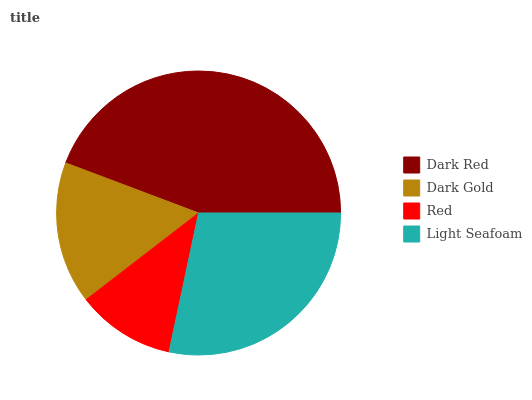Is Red the minimum?
Answer yes or no. Yes. Is Dark Red the maximum?
Answer yes or no. Yes. Is Dark Gold the minimum?
Answer yes or no. No. Is Dark Gold the maximum?
Answer yes or no. No. Is Dark Red greater than Dark Gold?
Answer yes or no. Yes. Is Dark Gold less than Dark Red?
Answer yes or no. Yes. Is Dark Gold greater than Dark Red?
Answer yes or no. No. Is Dark Red less than Dark Gold?
Answer yes or no. No. Is Light Seafoam the high median?
Answer yes or no. Yes. Is Dark Gold the low median?
Answer yes or no. Yes. Is Dark Red the high median?
Answer yes or no. No. Is Light Seafoam the low median?
Answer yes or no. No. 